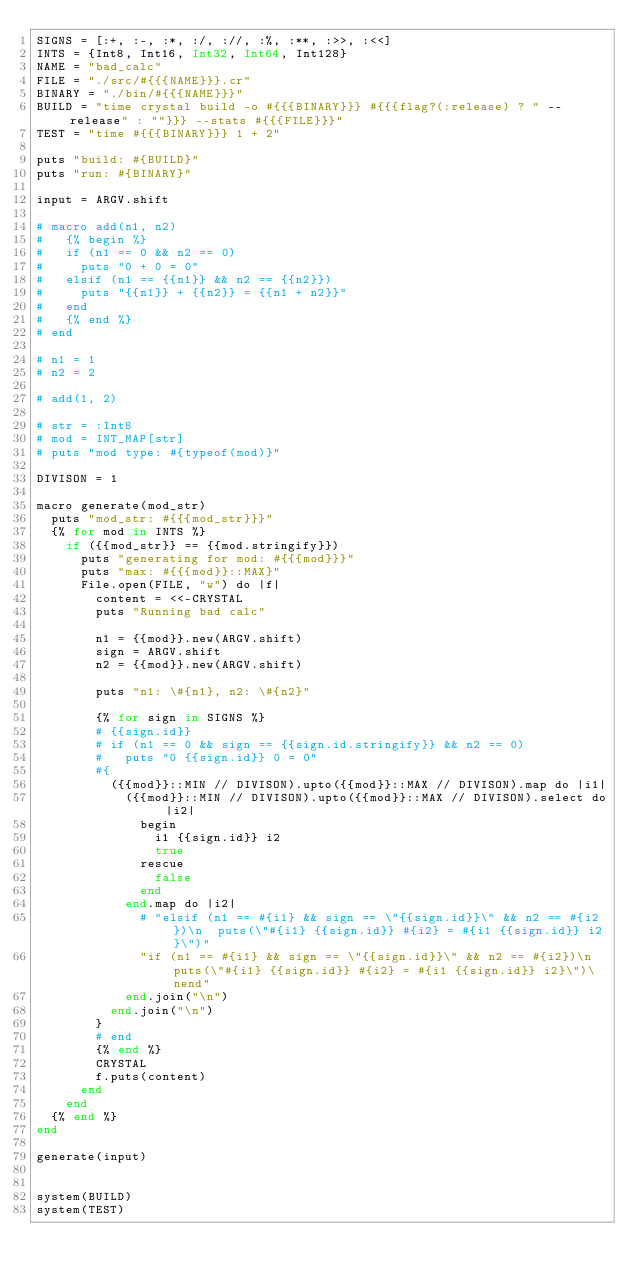Convert code to text. <code><loc_0><loc_0><loc_500><loc_500><_Crystal_>SIGNS = [:+, :-, :*, :/, ://, :%, :**, :>>, :<<]
INTS = {Int8, Int16, Int32, Int64, Int128}
NAME = "bad_calc"
FILE = "./src/#{{{NAME}}}.cr"
BINARY = "./bin/#{{{NAME}}}"
BUILD = "time crystal build -o #{{{BINARY}}} #{{{flag?(:release) ? " --release" : ""}}} --stats #{{{FILE}}}"
TEST = "time #{{{BINARY}}} 1 + 2"

puts "build: #{BUILD}"
puts "run: #{BINARY}"

input = ARGV.shift

# macro add(n1, n2)
#   {% begin %}
#   if (n1 == 0 && n2 == 0)
#     puts "0 + 0 = 0"
#   elsif (n1 == {{n1}} && n2 == {{n2}})
#     puts "{{n1}} + {{n2}} = {{n1 + n2}}"
#   end
#   {% end %}
# end

# n1 = 1
# n2 = 2

# add(1, 2)

# str = :Int8
# mod = INT_MAP[str]
# puts "mod type: #{typeof(mod)}"

DIVISON = 1

macro generate(mod_str)
  puts "mod_str: #{{{mod_str}}}"
  {% for mod in INTS %}
    if ({{mod_str}} == {{mod.stringify}})
      puts "generating for mod: #{{{mod}}}"
      puts "max: #{{{mod}}::MAX}"
      File.open(FILE, "w") do |f|
        content = <<-CRYSTAL
        puts "Running bad calc"

        n1 = {{mod}}.new(ARGV.shift)
        sign = ARGV.shift
        n2 = {{mod}}.new(ARGV.shift)

        puts "n1: \#{n1}, n2: \#{n2}"
        
        {% for sign in SIGNS %}
        # {{sign.id}}
        # if (n1 == 0 && sign == {{sign.id.stringify}} && n2 == 0)
        #   puts "0 {{sign.id}} 0 = 0"
        #{
          ({{mod}}::MIN // DIVISON).upto({{mod}}::MAX // DIVISON).map do |i1| 
            ({{mod}}::MIN // DIVISON).upto({{mod}}::MAX // DIVISON).select do |i2|
              begin
                i1 {{sign.id}} i2
                true
              rescue
                false
              end
            end.map do |i2|
              # "elsif (n1 == #{i1} && sign == \"{{sign.id}}\" && n2 == #{i2})\n  puts(\"#{i1} {{sign.id}} #{i2} = #{i1 {{sign.id}} i2}\")"
              "if (n1 == #{i1} && sign == \"{{sign.id}}\" && n2 == #{i2})\n  puts(\"#{i1} {{sign.id}} #{i2} = #{i1 {{sign.id}} i2}\")\nend"
            end.join("\n")
          end.join("\n")
        }
        # end
        {% end %}
        CRYSTAL
        f.puts(content)
      end
    end
  {% end %}
end

generate(input)


system(BUILD)
system(TEST)

</code> 